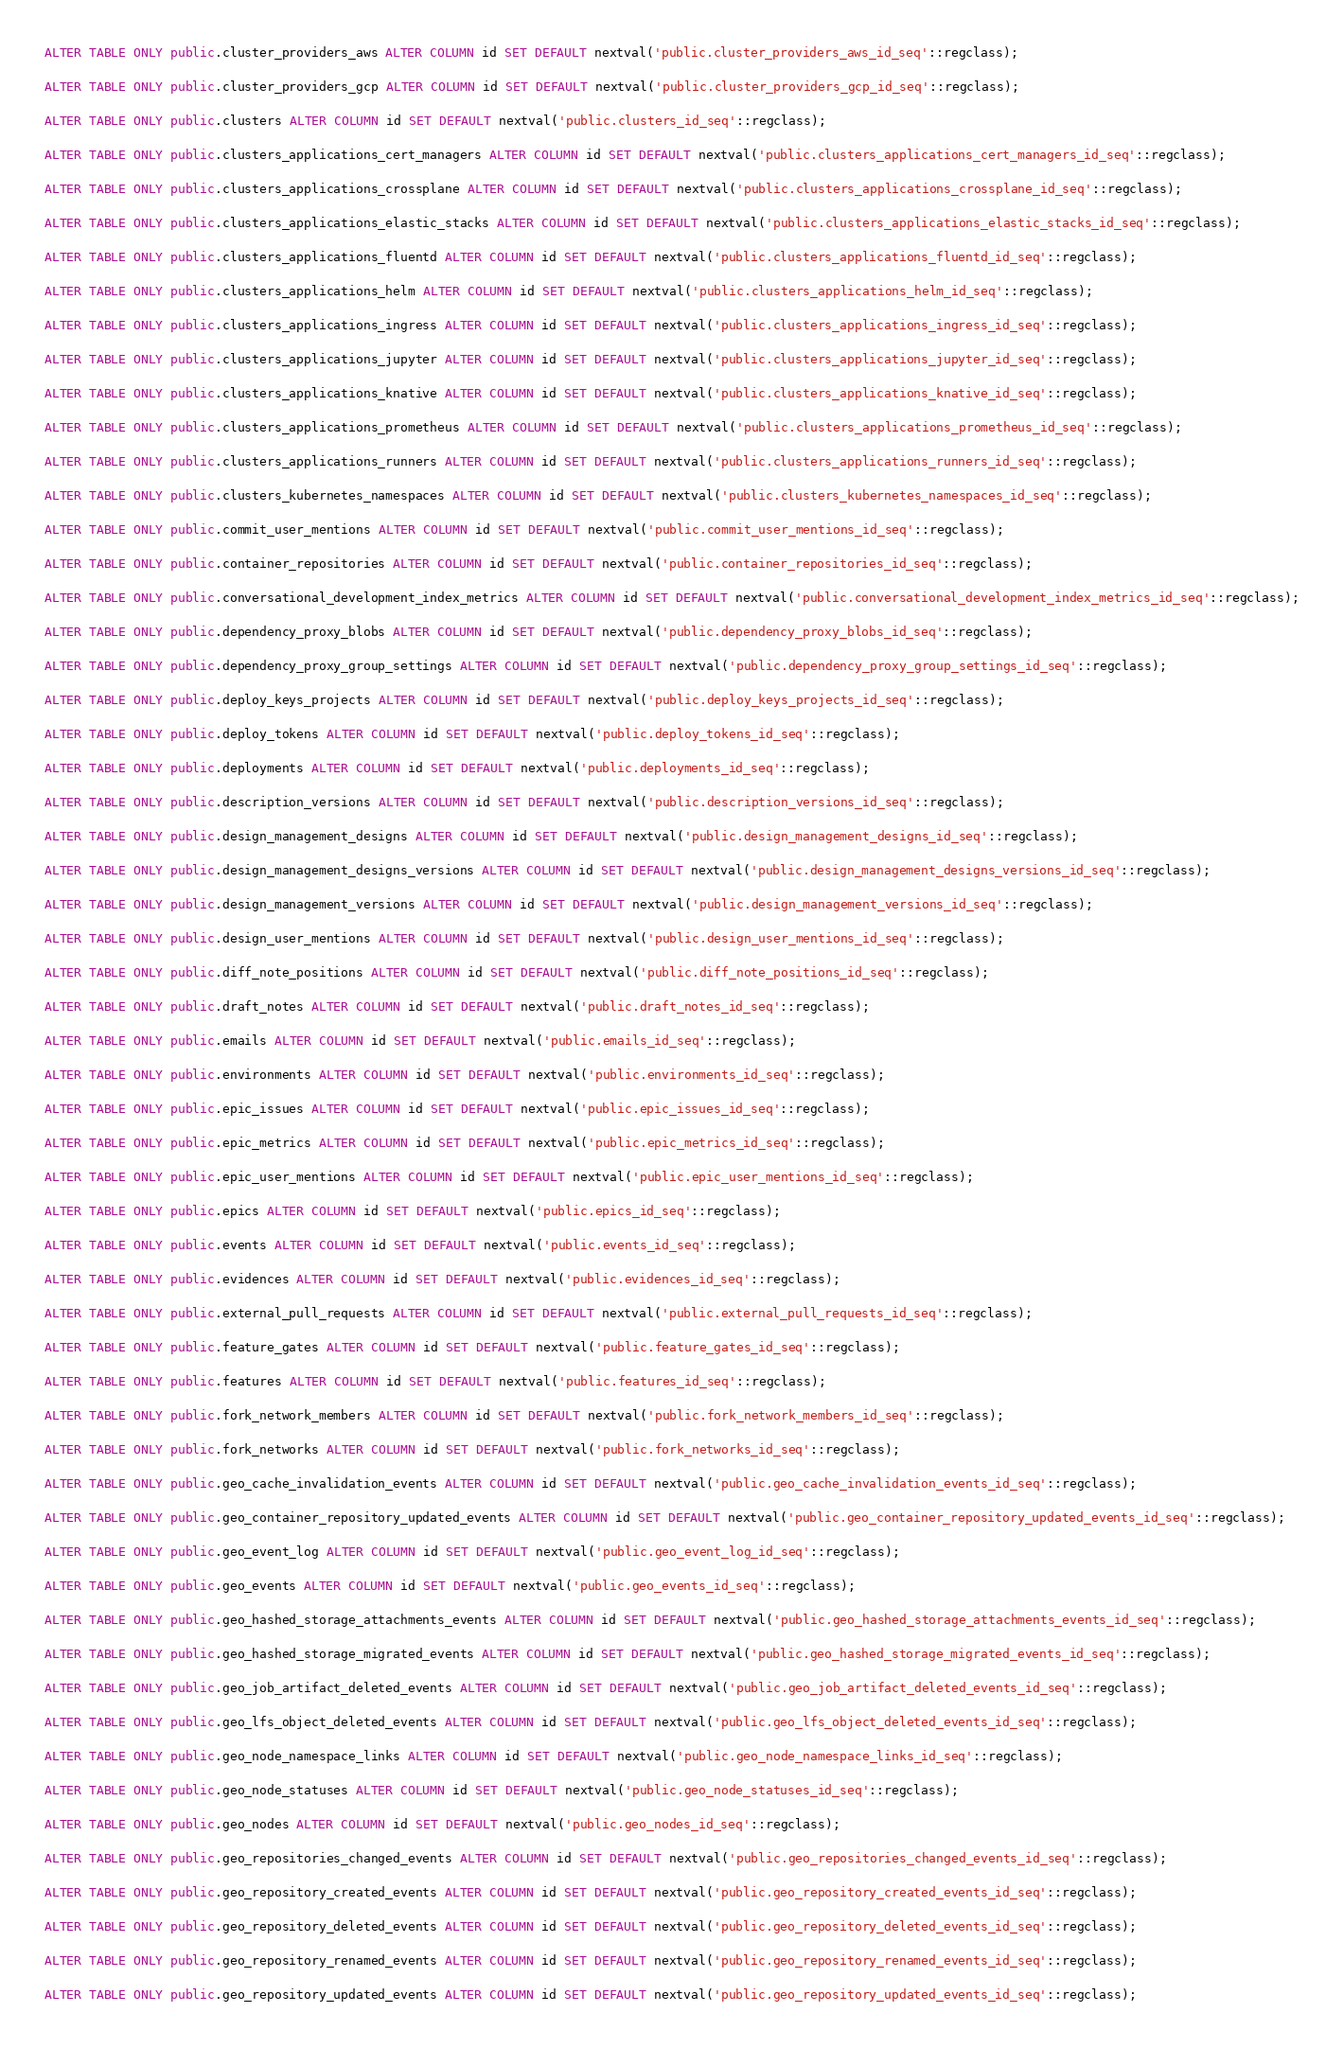<code> <loc_0><loc_0><loc_500><loc_500><_SQL_>
ALTER TABLE ONLY public.cluster_providers_aws ALTER COLUMN id SET DEFAULT nextval('public.cluster_providers_aws_id_seq'::regclass);

ALTER TABLE ONLY public.cluster_providers_gcp ALTER COLUMN id SET DEFAULT nextval('public.cluster_providers_gcp_id_seq'::regclass);

ALTER TABLE ONLY public.clusters ALTER COLUMN id SET DEFAULT nextval('public.clusters_id_seq'::regclass);

ALTER TABLE ONLY public.clusters_applications_cert_managers ALTER COLUMN id SET DEFAULT nextval('public.clusters_applications_cert_managers_id_seq'::regclass);

ALTER TABLE ONLY public.clusters_applications_crossplane ALTER COLUMN id SET DEFAULT nextval('public.clusters_applications_crossplane_id_seq'::regclass);

ALTER TABLE ONLY public.clusters_applications_elastic_stacks ALTER COLUMN id SET DEFAULT nextval('public.clusters_applications_elastic_stacks_id_seq'::regclass);

ALTER TABLE ONLY public.clusters_applications_fluentd ALTER COLUMN id SET DEFAULT nextval('public.clusters_applications_fluentd_id_seq'::regclass);

ALTER TABLE ONLY public.clusters_applications_helm ALTER COLUMN id SET DEFAULT nextval('public.clusters_applications_helm_id_seq'::regclass);

ALTER TABLE ONLY public.clusters_applications_ingress ALTER COLUMN id SET DEFAULT nextval('public.clusters_applications_ingress_id_seq'::regclass);

ALTER TABLE ONLY public.clusters_applications_jupyter ALTER COLUMN id SET DEFAULT nextval('public.clusters_applications_jupyter_id_seq'::regclass);

ALTER TABLE ONLY public.clusters_applications_knative ALTER COLUMN id SET DEFAULT nextval('public.clusters_applications_knative_id_seq'::regclass);

ALTER TABLE ONLY public.clusters_applications_prometheus ALTER COLUMN id SET DEFAULT nextval('public.clusters_applications_prometheus_id_seq'::regclass);

ALTER TABLE ONLY public.clusters_applications_runners ALTER COLUMN id SET DEFAULT nextval('public.clusters_applications_runners_id_seq'::regclass);

ALTER TABLE ONLY public.clusters_kubernetes_namespaces ALTER COLUMN id SET DEFAULT nextval('public.clusters_kubernetes_namespaces_id_seq'::regclass);

ALTER TABLE ONLY public.commit_user_mentions ALTER COLUMN id SET DEFAULT nextval('public.commit_user_mentions_id_seq'::regclass);

ALTER TABLE ONLY public.container_repositories ALTER COLUMN id SET DEFAULT nextval('public.container_repositories_id_seq'::regclass);

ALTER TABLE ONLY public.conversational_development_index_metrics ALTER COLUMN id SET DEFAULT nextval('public.conversational_development_index_metrics_id_seq'::regclass);

ALTER TABLE ONLY public.dependency_proxy_blobs ALTER COLUMN id SET DEFAULT nextval('public.dependency_proxy_blobs_id_seq'::regclass);

ALTER TABLE ONLY public.dependency_proxy_group_settings ALTER COLUMN id SET DEFAULT nextval('public.dependency_proxy_group_settings_id_seq'::regclass);

ALTER TABLE ONLY public.deploy_keys_projects ALTER COLUMN id SET DEFAULT nextval('public.deploy_keys_projects_id_seq'::regclass);

ALTER TABLE ONLY public.deploy_tokens ALTER COLUMN id SET DEFAULT nextval('public.deploy_tokens_id_seq'::regclass);

ALTER TABLE ONLY public.deployments ALTER COLUMN id SET DEFAULT nextval('public.deployments_id_seq'::regclass);

ALTER TABLE ONLY public.description_versions ALTER COLUMN id SET DEFAULT nextval('public.description_versions_id_seq'::regclass);

ALTER TABLE ONLY public.design_management_designs ALTER COLUMN id SET DEFAULT nextval('public.design_management_designs_id_seq'::regclass);

ALTER TABLE ONLY public.design_management_designs_versions ALTER COLUMN id SET DEFAULT nextval('public.design_management_designs_versions_id_seq'::regclass);

ALTER TABLE ONLY public.design_management_versions ALTER COLUMN id SET DEFAULT nextval('public.design_management_versions_id_seq'::regclass);

ALTER TABLE ONLY public.design_user_mentions ALTER COLUMN id SET DEFAULT nextval('public.design_user_mentions_id_seq'::regclass);

ALTER TABLE ONLY public.diff_note_positions ALTER COLUMN id SET DEFAULT nextval('public.diff_note_positions_id_seq'::regclass);

ALTER TABLE ONLY public.draft_notes ALTER COLUMN id SET DEFAULT nextval('public.draft_notes_id_seq'::regclass);

ALTER TABLE ONLY public.emails ALTER COLUMN id SET DEFAULT nextval('public.emails_id_seq'::regclass);

ALTER TABLE ONLY public.environments ALTER COLUMN id SET DEFAULT nextval('public.environments_id_seq'::regclass);

ALTER TABLE ONLY public.epic_issues ALTER COLUMN id SET DEFAULT nextval('public.epic_issues_id_seq'::regclass);

ALTER TABLE ONLY public.epic_metrics ALTER COLUMN id SET DEFAULT nextval('public.epic_metrics_id_seq'::regclass);

ALTER TABLE ONLY public.epic_user_mentions ALTER COLUMN id SET DEFAULT nextval('public.epic_user_mentions_id_seq'::regclass);

ALTER TABLE ONLY public.epics ALTER COLUMN id SET DEFAULT nextval('public.epics_id_seq'::regclass);

ALTER TABLE ONLY public.events ALTER COLUMN id SET DEFAULT nextval('public.events_id_seq'::regclass);

ALTER TABLE ONLY public.evidences ALTER COLUMN id SET DEFAULT nextval('public.evidences_id_seq'::regclass);

ALTER TABLE ONLY public.external_pull_requests ALTER COLUMN id SET DEFAULT nextval('public.external_pull_requests_id_seq'::regclass);

ALTER TABLE ONLY public.feature_gates ALTER COLUMN id SET DEFAULT nextval('public.feature_gates_id_seq'::regclass);

ALTER TABLE ONLY public.features ALTER COLUMN id SET DEFAULT nextval('public.features_id_seq'::regclass);

ALTER TABLE ONLY public.fork_network_members ALTER COLUMN id SET DEFAULT nextval('public.fork_network_members_id_seq'::regclass);

ALTER TABLE ONLY public.fork_networks ALTER COLUMN id SET DEFAULT nextval('public.fork_networks_id_seq'::regclass);

ALTER TABLE ONLY public.geo_cache_invalidation_events ALTER COLUMN id SET DEFAULT nextval('public.geo_cache_invalidation_events_id_seq'::regclass);

ALTER TABLE ONLY public.geo_container_repository_updated_events ALTER COLUMN id SET DEFAULT nextval('public.geo_container_repository_updated_events_id_seq'::regclass);

ALTER TABLE ONLY public.geo_event_log ALTER COLUMN id SET DEFAULT nextval('public.geo_event_log_id_seq'::regclass);

ALTER TABLE ONLY public.geo_events ALTER COLUMN id SET DEFAULT nextval('public.geo_events_id_seq'::regclass);

ALTER TABLE ONLY public.geo_hashed_storage_attachments_events ALTER COLUMN id SET DEFAULT nextval('public.geo_hashed_storage_attachments_events_id_seq'::regclass);

ALTER TABLE ONLY public.geo_hashed_storage_migrated_events ALTER COLUMN id SET DEFAULT nextval('public.geo_hashed_storage_migrated_events_id_seq'::regclass);

ALTER TABLE ONLY public.geo_job_artifact_deleted_events ALTER COLUMN id SET DEFAULT nextval('public.geo_job_artifact_deleted_events_id_seq'::regclass);

ALTER TABLE ONLY public.geo_lfs_object_deleted_events ALTER COLUMN id SET DEFAULT nextval('public.geo_lfs_object_deleted_events_id_seq'::regclass);

ALTER TABLE ONLY public.geo_node_namespace_links ALTER COLUMN id SET DEFAULT nextval('public.geo_node_namespace_links_id_seq'::regclass);

ALTER TABLE ONLY public.geo_node_statuses ALTER COLUMN id SET DEFAULT nextval('public.geo_node_statuses_id_seq'::regclass);

ALTER TABLE ONLY public.geo_nodes ALTER COLUMN id SET DEFAULT nextval('public.geo_nodes_id_seq'::regclass);

ALTER TABLE ONLY public.geo_repositories_changed_events ALTER COLUMN id SET DEFAULT nextval('public.geo_repositories_changed_events_id_seq'::regclass);

ALTER TABLE ONLY public.geo_repository_created_events ALTER COLUMN id SET DEFAULT nextval('public.geo_repository_created_events_id_seq'::regclass);

ALTER TABLE ONLY public.geo_repository_deleted_events ALTER COLUMN id SET DEFAULT nextval('public.geo_repository_deleted_events_id_seq'::regclass);

ALTER TABLE ONLY public.geo_repository_renamed_events ALTER COLUMN id SET DEFAULT nextval('public.geo_repository_renamed_events_id_seq'::regclass);

ALTER TABLE ONLY public.geo_repository_updated_events ALTER COLUMN id SET DEFAULT nextval('public.geo_repository_updated_events_id_seq'::regclass);
</code> 